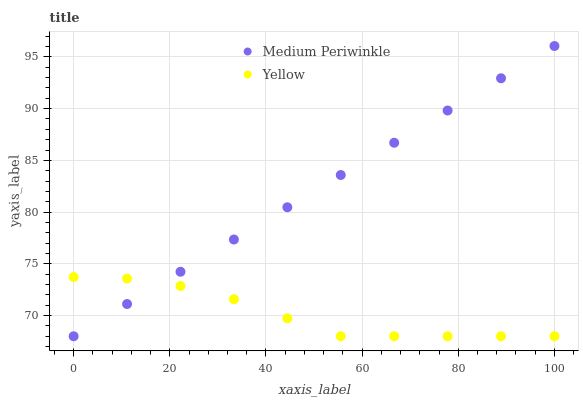Does Yellow have the minimum area under the curve?
Answer yes or no. Yes. Does Medium Periwinkle have the maximum area under the curve?
Answer yes or no. Yes. Does Yellow have the maximum area under the curve?
Answer yes or no. No. Is Medium Periwinkle the smoothest?
Answer yes or no. Yes. Is Yellow the roughest?
Answer yes or no. Yes. Is Yellow the smoothest?
Answer yes or no. No. Does Medium Periwinkle have the lowest value?
Answer yes or no. Yes. Does Medium Periwinkle have the highest value?
Answer yes or no. Yes. Does Yellow have the highest value?
Answer yes or no. No. Does Medium Periwinkle intersect Yellow?
Answer yes or no. Yes. Is Medium Periwinkle less than Yellow?
Answer yes or no. No. Is Medium Periwinkle greater than Yellow?
Answer yes or no. No. 